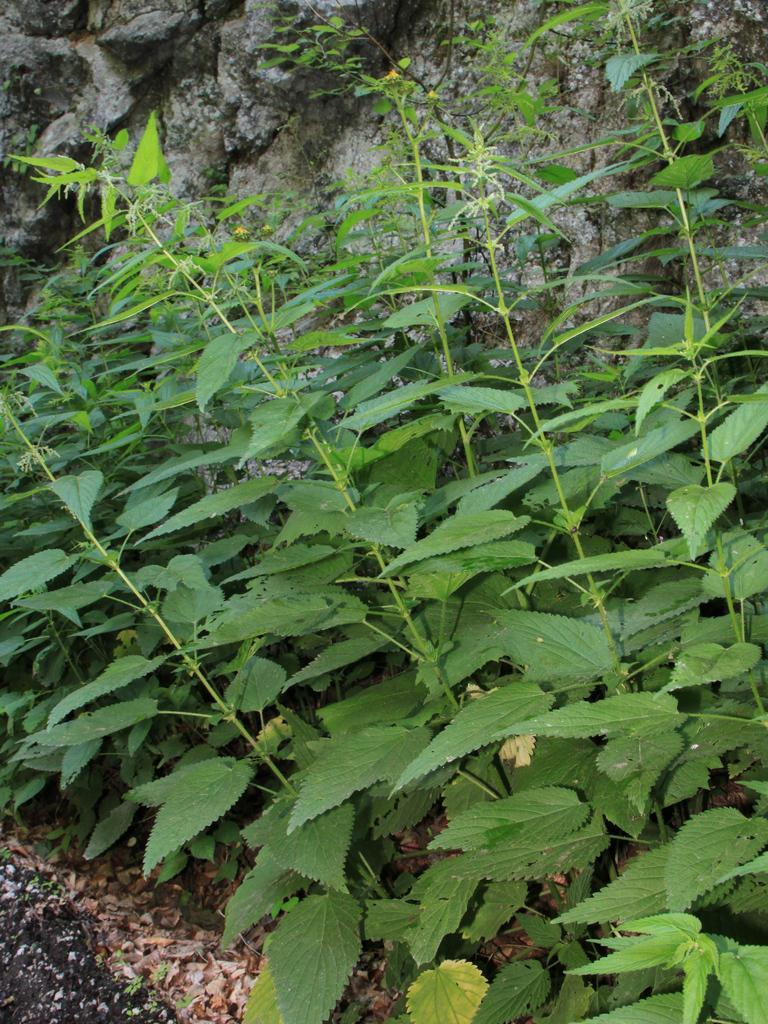What type of living organisms can be seen in the image? Plants can be seen in the image. What is on the ground in the image? There are dry leaves on the ground in the image. What can be seen in the background of the image? There is a wall in the background of the image. What word is the uncle saying in the image? There is no uncle or any spoken words present in the image. 